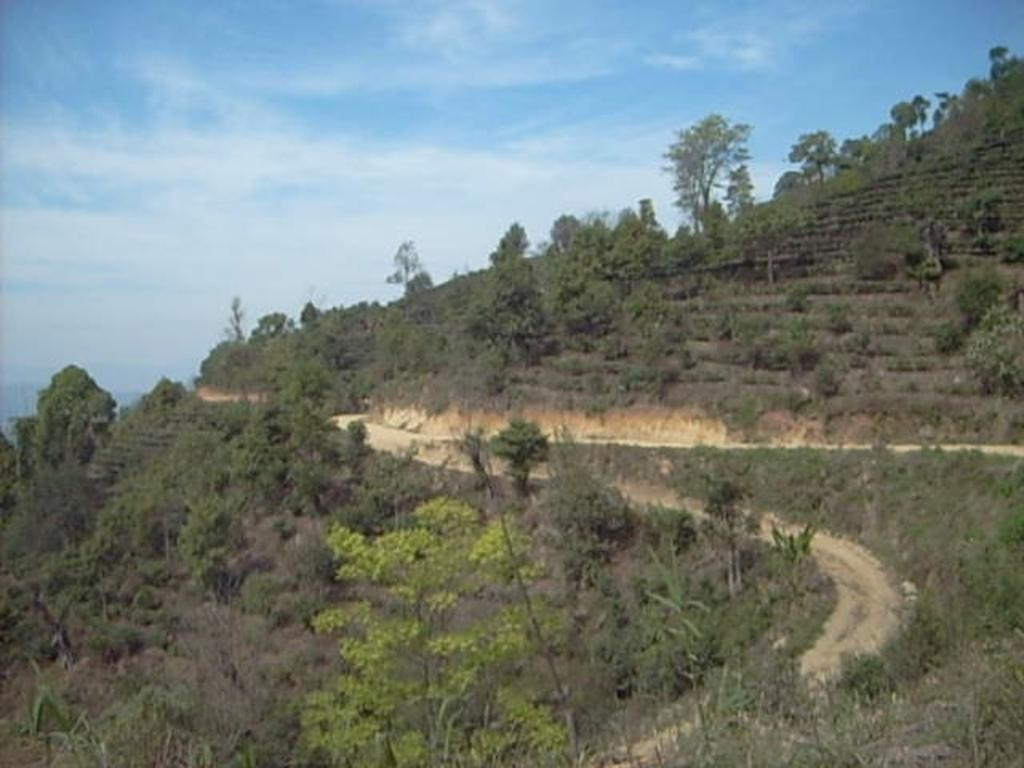What type of vegetation can be seen in the image? There are plants and a group of trees in the image. What is the terrain like in the image? There is a pathway on a hill in the image. What is visible in the sky in the image? The sky is visible in the image, and it appears cloudy. How many cows are wearing coats in the image? There are no cows or coats present in the image. 